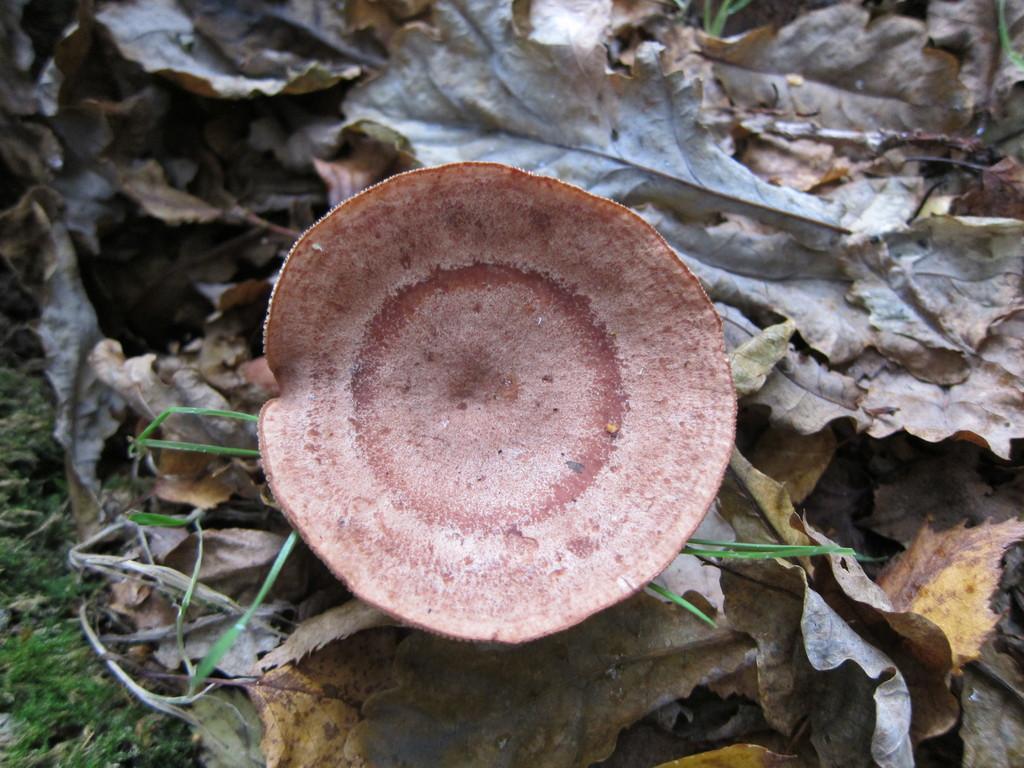Could you give a brief overview of what you see in this image? This image is taken outdoors. At the bottom of the image there is a ground with grass on it and there are many dry leaves on the ground. In the middle of the image there is a mushroom on the ground. 